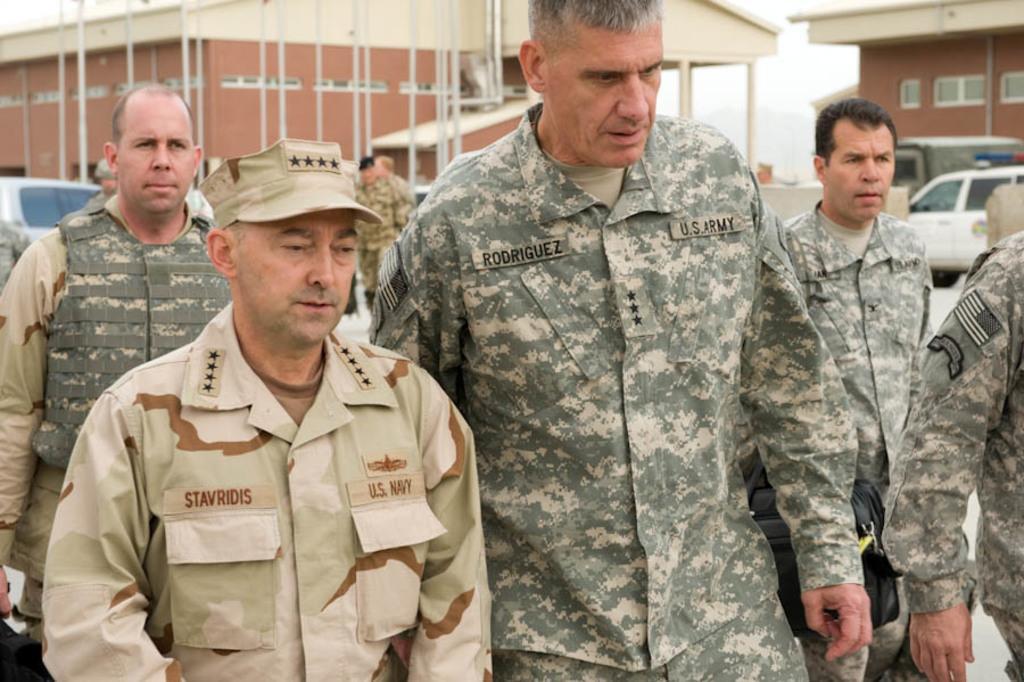How would you summarize this image in a sentence or two? In the picture, there are a group of soldiers walking on the ground and behind them there are two quarters and in front of those quarters some vehicles are parked. 